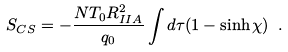Convert formula to latex. <formula><loc_0><loc_0><loc_500><loc_500>S _ { C S } = - \frac { N T _ { 0 } R _ { I I A } ^ { 2 } } { q _ { 0 } } \int d \tau ( 1 - \sinh \chi ) \ .</formula> 